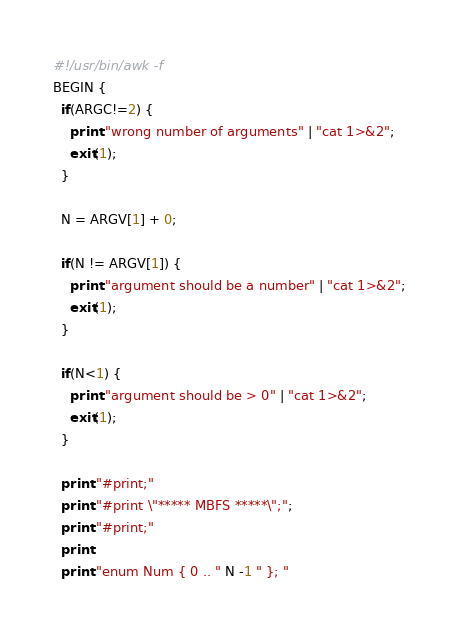Convert code to text. <code><loc_0><loc_0><loc_500><loc_500><_Awk_>#!/usr/bin/awk -f
BEGIN {
  if(ARGC!=2) {
    print "wrong number of arguments" | "cat 1>&2";
    exit(1);
  }

  N = ARGV[1] + 0;

  if(N != ARGV[1]) {
    print "argument should be a number" | "cat 1>&2";
    exit(1);
  }

  if(N<1) {
    print "argument should be > 0" | "cat 1>&2";
    exit(1);
  }

  print "#print;"
  print "#print \"***** MBFS *****\";";
  print "#print;"
  print
  print "enum Num { 0 .. " N -1 " }; "</code> 